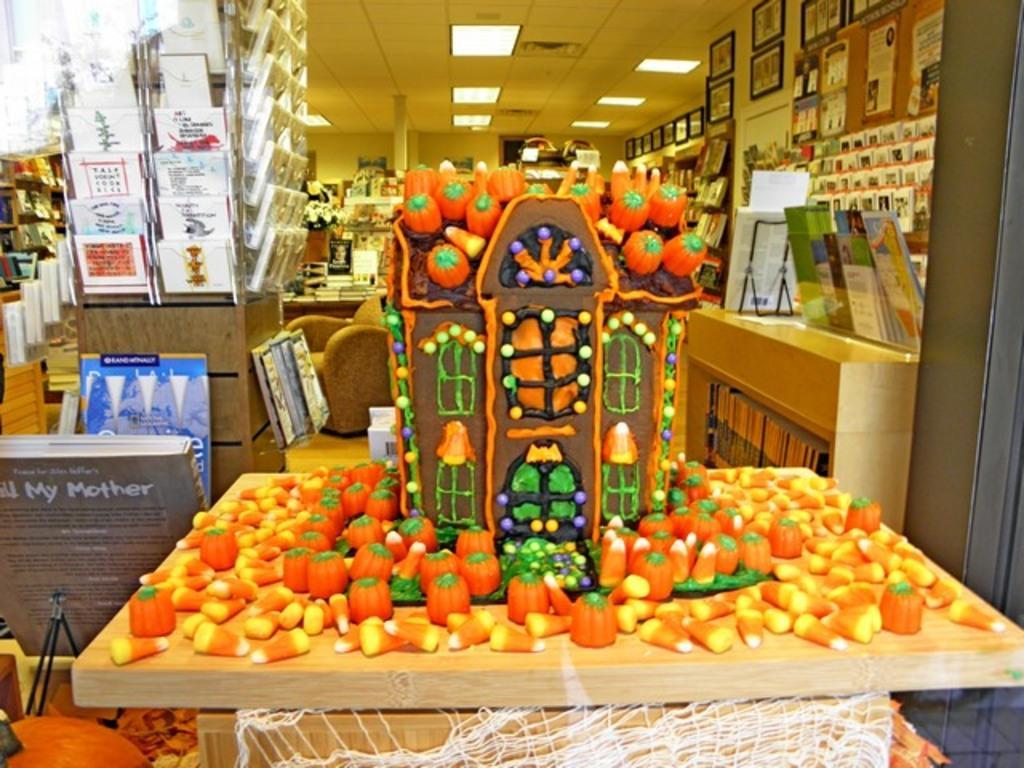Describe this image in one or two sentences. In this image we can see a house made with toys on the table, a net under a table. On the right side we can see some books in the shelf, papers in a stand and photo frames. On the left side we can see the books with a stand. On the backside we can see a flower pot, sofa, floor, walls, pillar, roof and ceiling lights. 